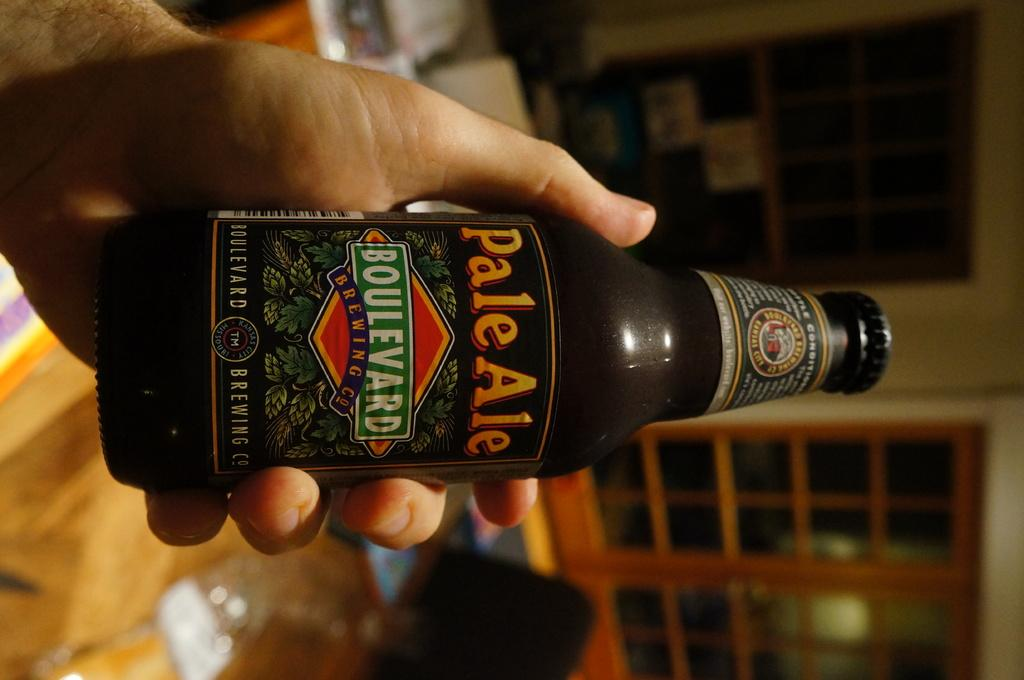<image>
Write a terse but informative summary of the picture. A bottle of pale ale from the Boulevard Brewing co. 